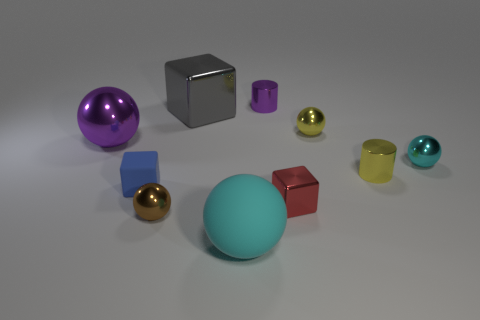Subtract all metallic balls. How many balls are left? 1 Subtract all blocks. How many objects are left? 7 Subtract 1 blocks. How many blocks are left? 2 Subtract all gray blocks. How many blocks are left? 2 Subtract 0 blue balls. How many objects are left? 10 Subtract all cyan cubes. Subtract all cyan balls. How many cubes are left? 3 Subtract all green cylinders. How many purple balls are left? 1 Subtract all small brown spheres. Subtract all purple metal cylinders. How many objects are left? 8 Add 5 gray metal things. How many gray metal things are left? 6 Add 6 big cyan balls. How many big cyan balls exist? 7 